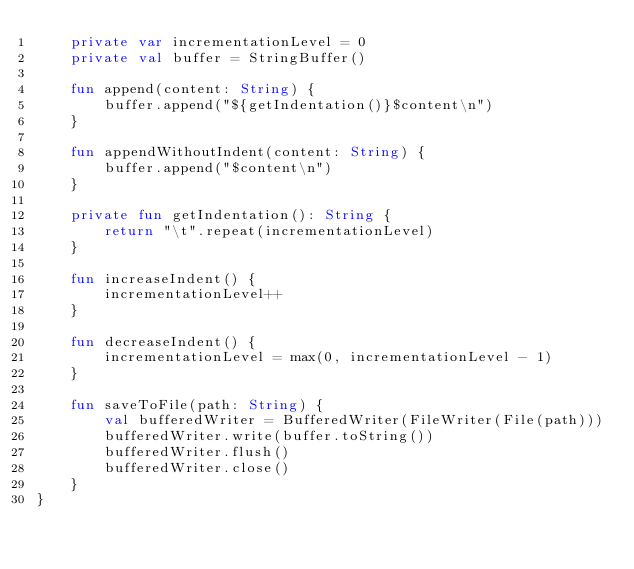<code> <loc_0><loc_0><loc_500><loc_500><_Kotlin_>    private var incrementationLevel = 0
    private val buffer = StringBuffer()

    fun append(content: String) {
        buffer.append("${getIndentation()}$content\n")
    }

    fun appendWithoutIndent(content: String) {
        buffer.append("$content\n")
    }

    private fun getIndentation(): String {
        return "\t".repeat(incrementationLevel)
    }

    fun increaseIndent() {
        incrementationLevel++
    }

    fun decreaseIndent() {
        incrementationLevel = max(0, incrementationLevel - 1)
    }

    fun saveToFile(path: String) {
        val bufferedWriter = BufferedWriter(FileWriter(File(path)))
        bufferedWriter.write(buffer.toString())
        bufferedWriter.flush()
        bufferedWriter.close()
    }
}
</code> 